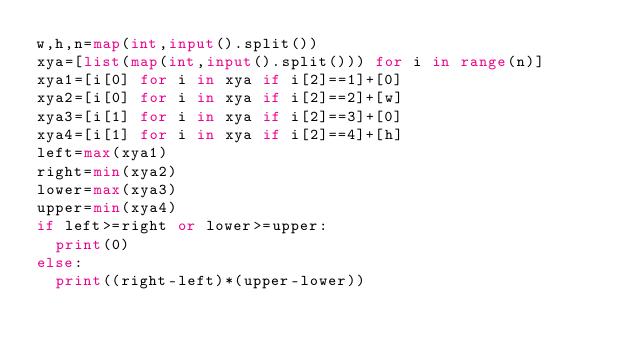<code> <loc_0><loc_0><loc_500><loc_500><_Python_>w,h,n=map(int,input().split())
xya=[list(map(int,input().split())) for i in range(n)]
xya1=[i[0] for i in xya if i[2]==1]+[0]
xya2=[i[0] for i in xya if i[2]==2]+[w]
xya3=[i[1] for i in xya if i[2]==3]+[0]
xya4=[i[1] for i in xya if i[2]==4]+[h]
left=max(xya1)
right=min(xya2)
lower=max(xya3)
upper=min(xya4)
if left>=right or lower>=upper:
  print(0)
else:
  print((right-left)*(upper-lower))</code> 